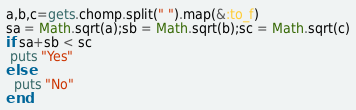<code> <loc_0><loc_0><loc_500><loc_500><_Ruby_>a,b,c=gets.chomp.split(" ").map(&:to_f)
sa = Math.sqrt(a);sb = Math.sqrt(b);sc = Math.sqrt(c)
if sa+sb < sc
 puts "Yes"
else
  puts "No"
end
</code> 